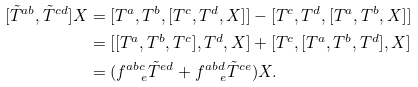<formula> <loc_0><loc_0><loc_500><loc_500>[ \tilde { T } ^ { a b } , \tilde { T } ^ { c d } ] X & = [ T ^ { a } , T ^ { b } , [ T ^ { c } , T ^ { d } , X ] ] - [ T ^ { c } , T ^ { d } , [ T ^ { a } , T ^ { b } , X ] ] \\ & = [ [ T ^ { a } , T ^ { b } , T ^ { c } ] , T ^ { d } , X ] + [ T ^ { c } , [ T ^ { a } , T ^ { b } , T ^ { d } ] , X ] \\ & = ( f ^ { a b c } _ { \quad e } \tilde { T } ^ { e d } + f ^ { a b d } _ { \quad e } \tilde { T } ^ { c e } ) X .</formula> 